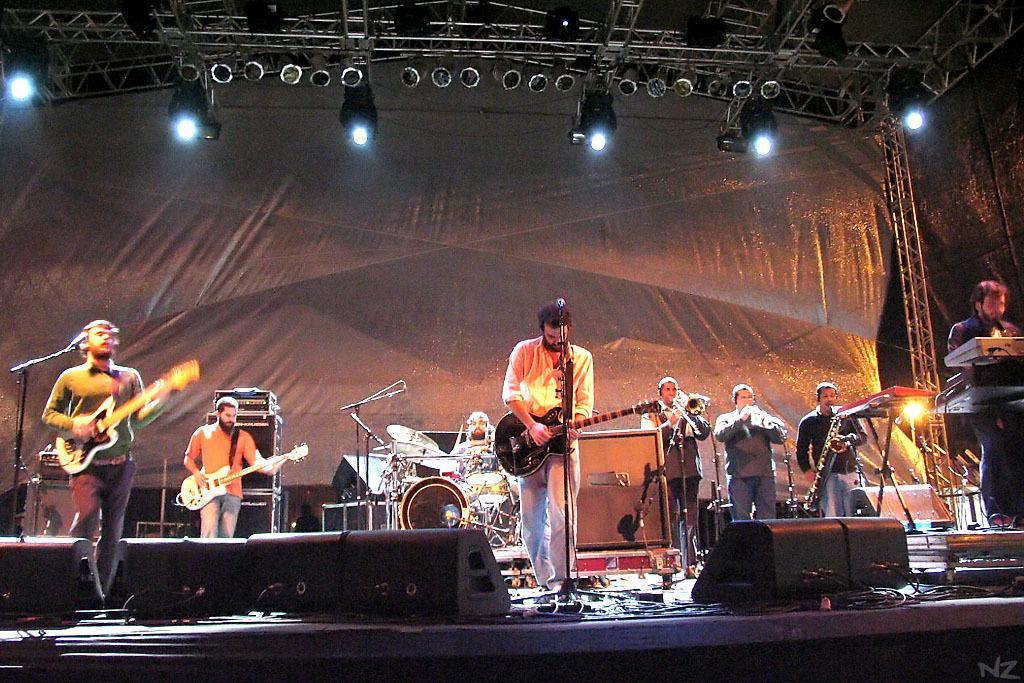How would you summarize this image in a sentence or two? some people are standing and playing guitar and few people are playing musical instantiations which are been placed at center of the stage. 